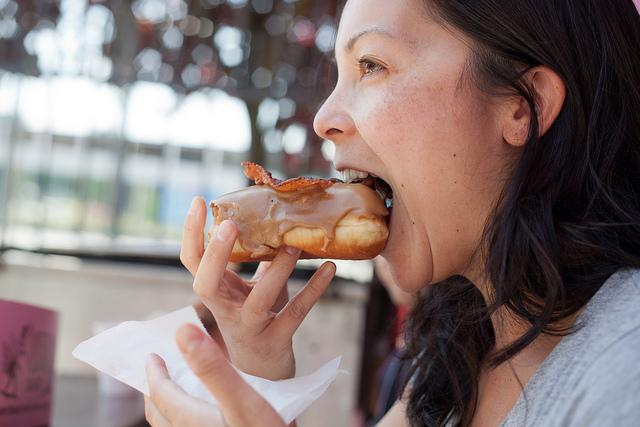Is what she's eating healthy?
Write a very short answer. No. No the person is not?
Concise answer only. Yes. What color is the woman's hair?
Quick response, please. Black. What is the woman eating?
Write a very short answer. Donut. What toppings are on the hot dog?
Give a very brief answer. Bacon. Is the person wearing glasses?
Write a very short answer. No. Is she eating an eclair?
Be succinct. Yes. 